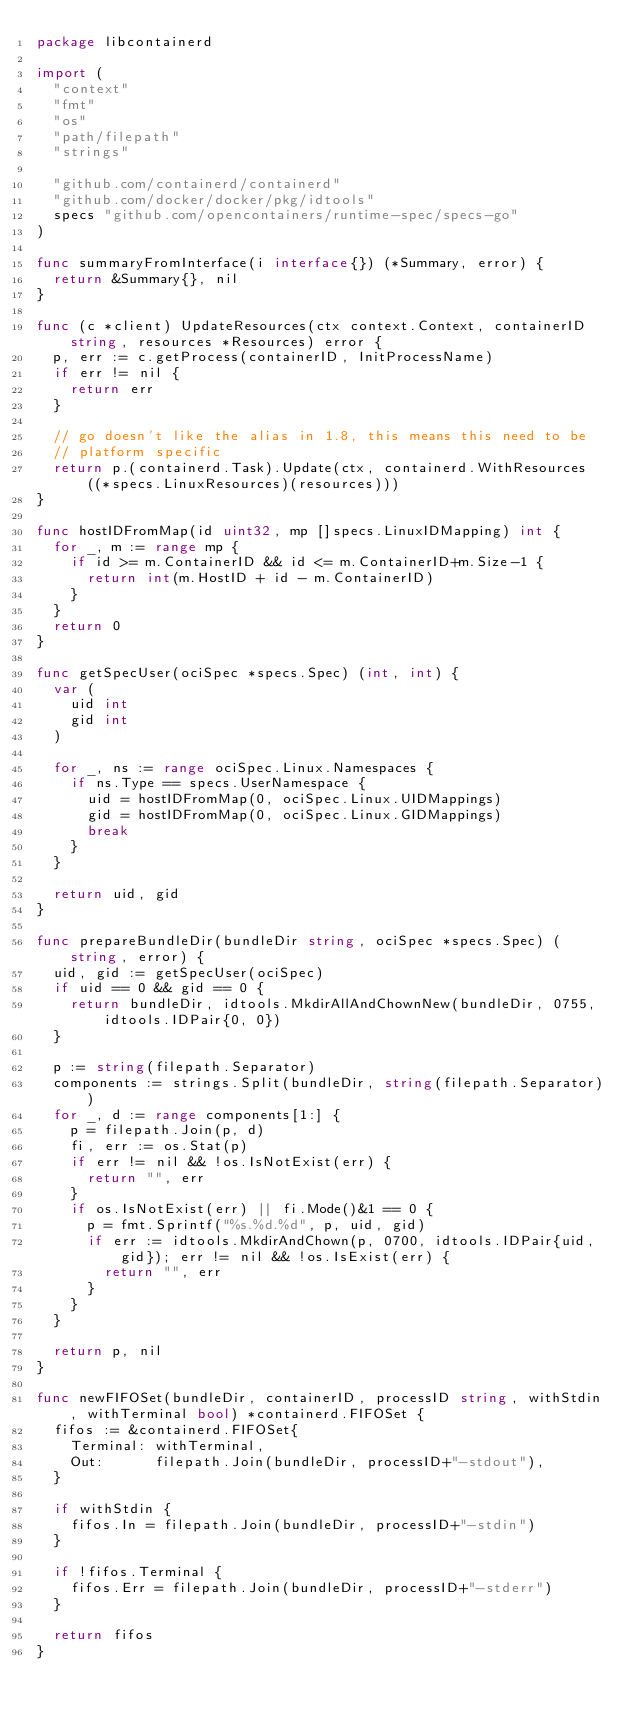Convert code to text. <code><loc_0><loc_0><loc_500><loc_500><_Go_>package libcontainerd

import (
	"context"
	"fmt"
	"os"
	"path/filepath"
	"strings"

	"github.com/containerd/containerd"
	"github.com/docker/docker/pkg/idtools"
	specs "github.com/opencontainers/runtime-spec/specs-go"
)

func summaryFromInterface(i interface{}) (*Summary, error) {
	return &Summary{}, nil
}

func (c *client) UpdateResources(ctx context.Context, containerID string, resources *Resources) error {
	p, err := c.getProcess(containerID, InitProcessName)
	if err != nil {
		return err
	}

	// go doesn't like the alias in 1.8, this means this need to be
	// platform specific
	return p.(containerd.Task).Update(ctx, containerd.WithResources((*specs.LinuxResources)(resources)))
}

func hostIDFromMap(id uint32, mp []specs.LinuxIDMapping) int {
	for _, m := range mp {
		if id >= m.ContainerID && id <= m.ContainerID+m.Size-1 {
			return int(m.HostID + id - m.ContainerID)
		}
	}
	return 0
}

func getSpecUser(ociSpec *specs.Spec) (int, int) {
	var (
		uid int
		gid int
	)

	for _, ns := range ociSpec.Linux.Namespaces {
		if ns.Type == specs.UserNamespace {
			uid = hostIDFromMap(0, ociSpec.Linux.UIDMappings)
			gid = hostIDFromMap(0, ociSpec.Linux.GIDMappings)
			break
		}
	}

	return uid, gid
}

func prepareBundleDir(bundleDir string, ociSpec *specs.Spec) (string, error) {
	uid, gid := getSpecUser(ociSpec)
	if uid == 0 && gid == 0 {
		return bundleDir, idtools.MkdirAllAndChownNew(bundleDir, 0755, idtools.IDPair{0, 0})
	}

	p := string(filepath.Separator)
	components := strings.Split(bundleDir, string(filepath.Separator))
	for _, d := range components[1:] {
		p = filepath.Join(p, d)
		fi, err := os.Stat(p)
		if err != nil && !os.IsNotExist(err) {
			return "", err
		}
		if os.IsNotExist(err) || fi.Mode()&1 == 0 {
			p = fmt.Sprintf("%s.%d.%d", p, uid, gid)
			if err := idtools.MkdirAndChown(p, 0700, idtools.IDPair{uid, gid}); err != nil && !os.IsExist(err) {
				return "", err
			}
		}
	}

	return p, nil
}

func newFIFOSet(bundleDir, containerID, processID string, withStdin, withTerminal bool) *containerd.FIFOSet {
	fifos := &containerd.FIFOSet{
		Terminal: withTerminal,
		Out:      filepath.Join(bundleDir, processID+"-stdout"),
	}

	if withStdin {
		fifos.In = filepath.Join(bundleDir, processID+"-stdin")
	}

	if !fifos.Terminal {
		fifos.Err = filepath.Join(bundleDir, processID+"-stderr")
	}

	return fifos
}
</code> 